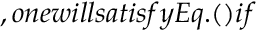Convert formula to latex. <formula><loc_0><loc_0><loc_500><loc_500>, o n e w i l l s a t i s f y E q . ( ) i f</formula> 